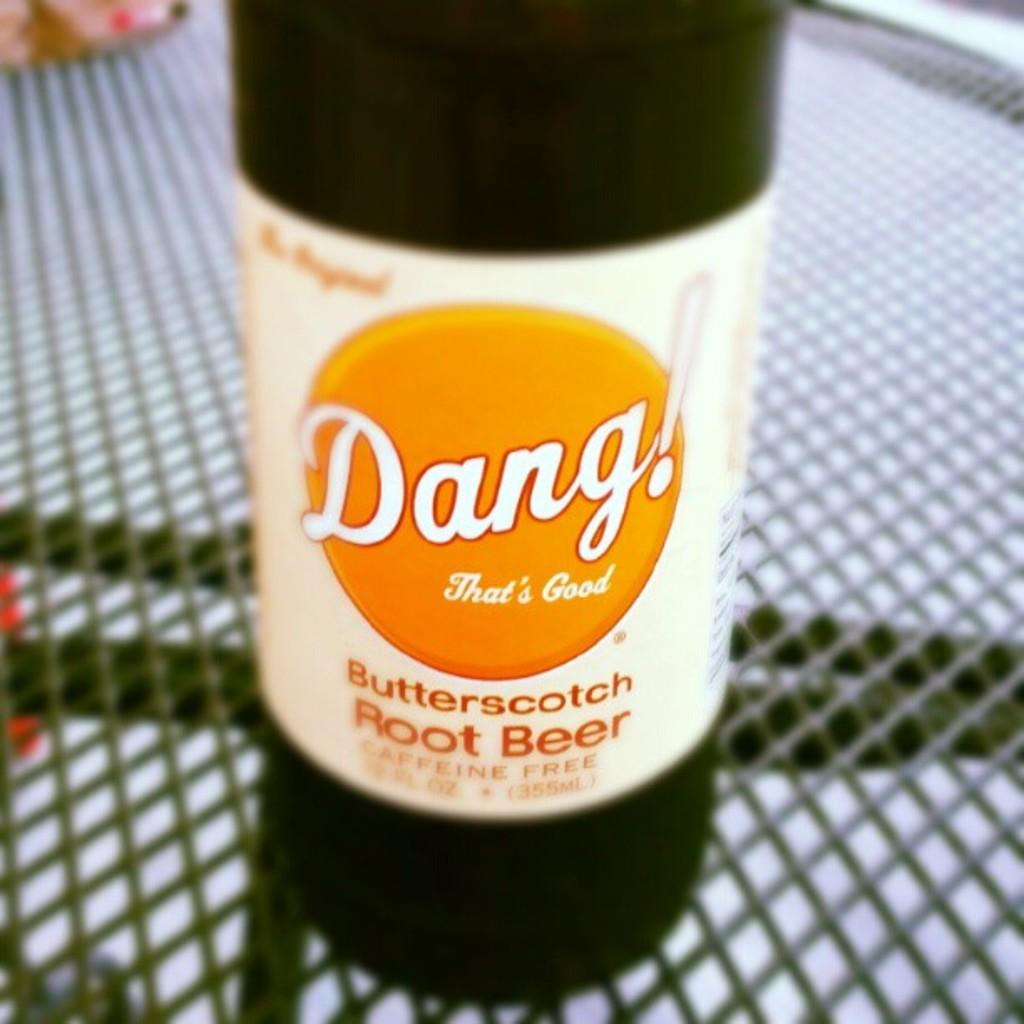<image>
Render a clear and concise summary of the photo. A bottle of caffeine free root beer from the Dang that's good brand. . 